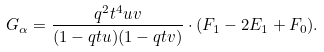<formula> <loc_0><loc_0><loc_500><loc_500>G _ { \alpha } = \frac { q ^ { 2 } t ^ { 4 } u v } { ( 1 - q t u ) ( 1 - q t v ) } \cdot ( F _ { 1 } - 2 E _ { 1 } + F _ { 0 } ) .</formula> 